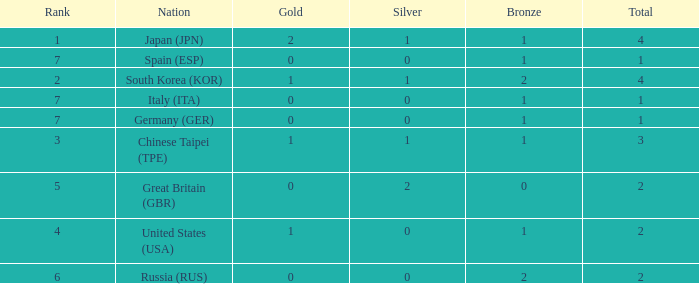What is the smallest number of gold of a country of rank 6, with 2 bronzes? None. 